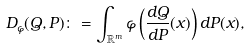Convert formula to latex. <formula><loc_0><loc_0><loc_500><loc_500>D _ { \varphi } ( Q , P ) \colon = \int _ { \mathbb { R } ^ { m } } \varphi \left ( \frac { d Q } { d P } ( x ) \right ) d P ( x ) ,</formula> 